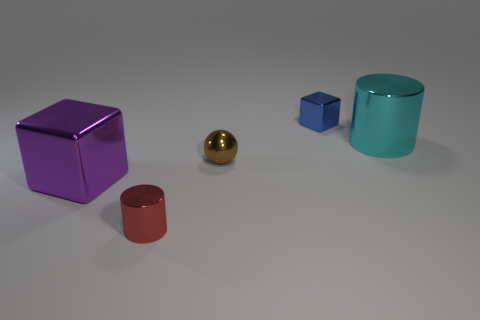Subtract all spheres. How many objects are left? 4 Subtract 2 blocks. How many blocks are left? 0 Subtract all cyan balls. Subtract all purple blocks. How many balls are left? 1 Subtract all brown cylinders. How many cyan spheres are left? 0 Subtract all cyan shiny things. Subtract all tiny red objects. How many objects are left? 3 Add 5 metal balls. How many metal balls are left? 6 Add 5 red things. How many red things exist? 6 Add 2 green matte cylinders. How many objects exist? 7 Subtract all purple cubes. How many cubes are left? 1 Subtract 0 gray cubes. How many objects are left? 5 